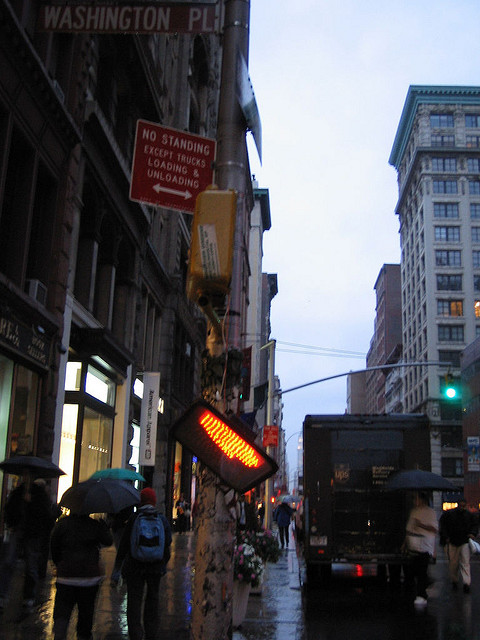Please extract the text content from this image. NO STANDING WASHINGTON PL LOADING UNLOADING 